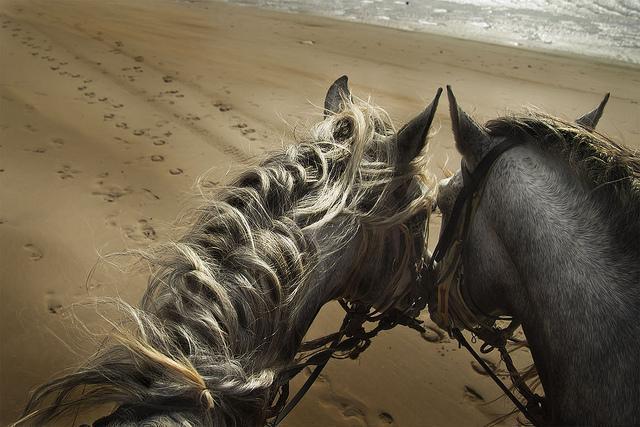How many horses can be seen?
Give a very brief answer. 2. 